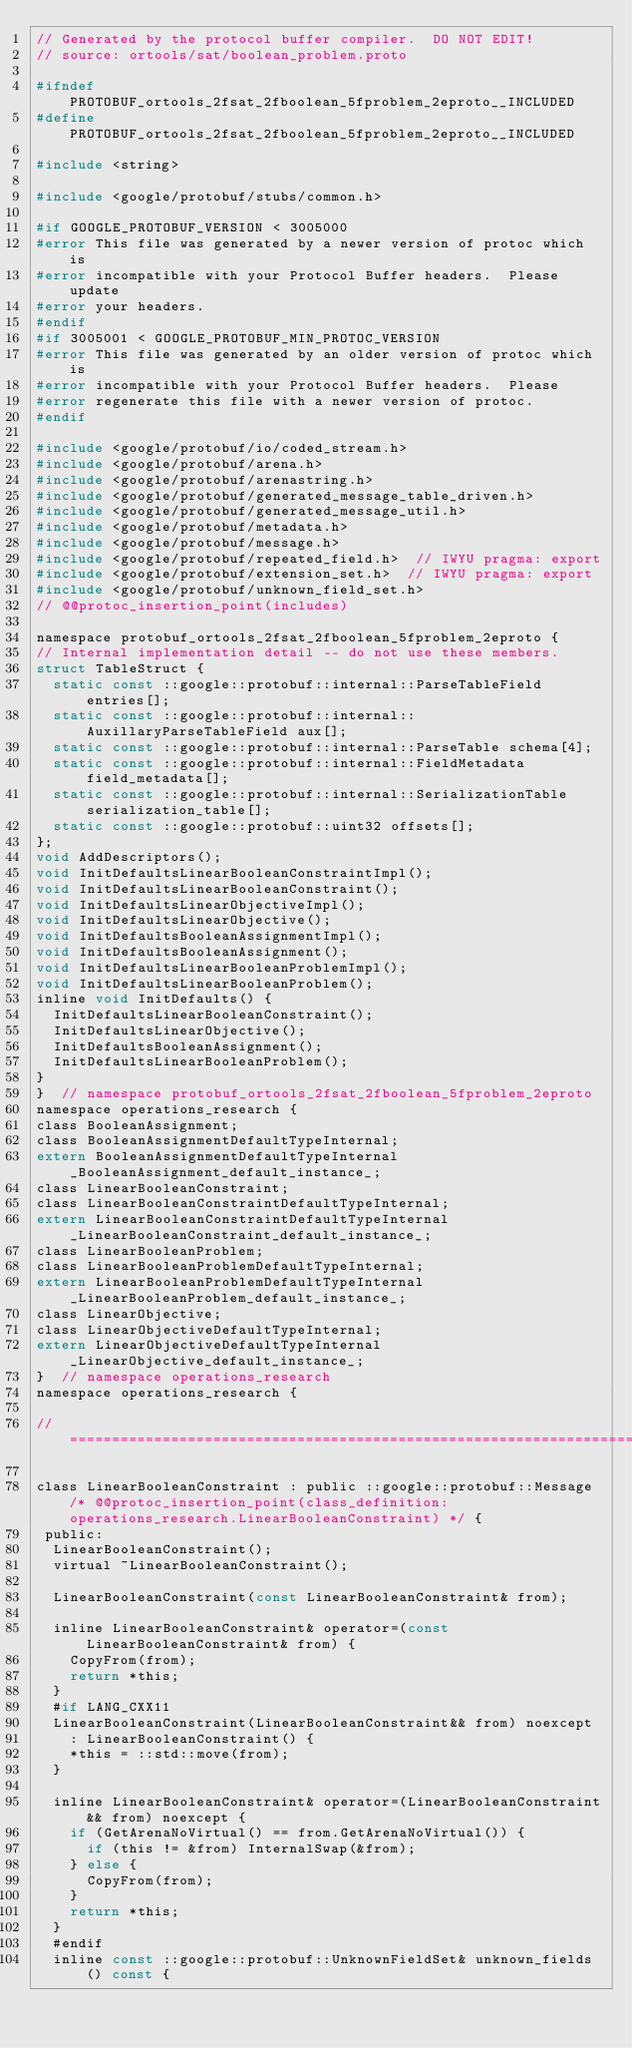<code> <loc_0><loc_0><loc_500><loc_500><_C_>// Generated by the protocol buffer compiler.  DO NOT EDIT!
// source: ortools/sat/boolean_problem.proto

#ifndef PROTOBUF_ortools_2fsat_2fboolean_5fproblem_2eproto__INCLUDED
#define PROTOBUF_ortools_2fsat_2fboolean_5fproblem_2eproto__INCLUDED

#include <string>

#include <google/protobuf/stubs/common.h>

#if GOOGLE_PROTOBUF_VERSION < 3005000
#error This file was generated by a newer version of protoc which is
#error incompatible with your Protocol Buffer headers.  Please update
#error your headers.
#endif
#if 3005001 < GOOGLE_PROTOBUF_MIN_PROTOC_VERSION
#error This file was generated by an older version of protoc which is
#error incompatible with your Protocol Buffer headers.  Please
#error regenerate this file with a newer version of protoc.
#endif

#include <google/protobuf/io/coded_stream.h>
#include <google/protobuf/arena.h>
#include <google/protobuf/arenastring.h>
#include <google/protobuf/generated_message_table_driven.h>
#include <google/protobuf/generated_message_util.h>
#include <google/protobuf/metadata.h>
#include <google/protobuf/message.h>
#include <google/protobuf/repeated_field.h>  // IWYU pragma: export
#include <google/protobuf/extension_set.h>  // IWYU pragma: export
#include <google/protobuf/unknown_field_set.h>
// @@protoc_insertion_point(includes)

namespace protobuf_ortools_2fsat_2fboolean_5fproblem_2eproto {
// Internal implementation detail -- do not use these members.
struct TableStruct {
  static const ::google::protobuf::internal::ParseTableField entries[];
  static const ::google::protobuf::internal::AuxillaryParseTableField aux[];
  static const ::google::protobuf::internal::ParseTable schema[4];
  static const ::google::protobuf::internal::FieldMetadata field_metadata[];
  static const ::google::protobuf::internal::SerializationTable serialization_table[];
  static const ::google::protobuf::uint32 offsets[];
};
void AddDescriptors();
void InitDefaultsLinearBooleanConstraintImpl();
void InitDefaultsLinearBooleanConstraint();
void InitDefaultsLinearObjectiveImpl();
void InitDefaultsLinearObjective();
void InitDefaultsBooleanAssignmentImpl();
void InitDefaultsBooleanAssignment();
void InitDefaultsLinearBooleanProblemImpl();
void InitDefaultsLinearBooleanProblem();
inline void InitDefaults() {
  InitDefaultsLinearBooleanConstraint();
  InitDefaultsLinearObjective();
  InitDefaultsBooleanAssignment();
  InitDefaultsLinearBooleanProblem();
}
}  // namespace protobuf_ortools_2fsat_2fboolean_5fproblem_2eproto
namespace operations_research {
class BooleanAssignment;
class BooleanAssignmentDefaultTypeInternal;
extern BooleanAssignmentDefaultTypeInternal _BooleanAssignment_default_instance_;
class LinearBooleanConstraint;
class LinearBooleanConstraintDefaultTypeInternal;
extern LinearBooleanConstraintDefaultTypeInternal _LinearBooleanConstraint_default_instance_;
class LinearBooleanProblem;
class LinearBooleanProblemDefaultTypeInternal;
extern LinearBooleanProblemDefaultTypeInternal _LinearBooleanProblem_default_instance_;
class LinearObjective;
class LinearObjectiveDefaultTypeInternal;
extern LinearObjectiveDefaultTypeInternal _LinearObjective_default_instance_;
}  // namespace operations_research
namespace operations_research {

// ===================================================================

class LinearBooleanConstraint : public ::google::protobuf::Message /* @@protoc_insertion_point(class_definition:operations_research.LinearBooleanConstraint) */ {
 public:
  LinearBooleanConstraint();
  virtual ~LinearBooleanConstraint();

  LinearBooleanConstraint(const LinearBooleanConstraint& from);

  inline LinearBooleanConstraint& operator=(const LinearBooleanConstraint& from) {
    CopyFrom(from);
    return *this;
  }
  #if LANG_CXX11
  LinearBooleanConstraint(LinearBooleanConstraint&& from) noexcept
    : LinearBooleanConstraint() {
    *this = ::std::move(from);
  }

  inline LinearBooleanConstraint& operator=(LinearBooleanConstraint&& from) noexcept {
    if (GetArenaNoVirtual() == from.GetArenaNoVirtual()) {
      if (this != &from) InternalSwap(&from);
    } else {
      CopyFrom(from);
    }
    return *this;
  }
  #endif
  inline const ::google::protobuf::UnknownFieldSet& unknown_fields() const {</code> 